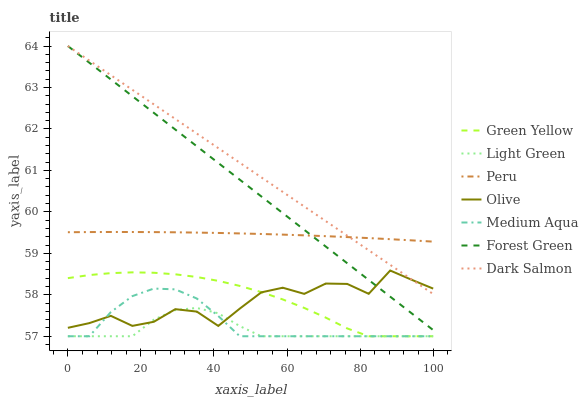Does Light Green have the minimum area under the curve?
Answer yes or no. Yes. Does Dark Salmon have the maximum area under the curve?
Answer yes or no. Yes. Does Forest Green have the minimum area under the curve?
Answer yes or no. No. Does Forest Green have the maximum area under the curve?
Answer yes or no. No. Is Forest Green the smoothest?
Answer yes or no. Yes. Is Olive the roughest?
Answer yes or no. Yes. Is Dark Salmon the smoothest?
Answer yes or no. No. Is Dark Salmon the roughest?
Answer yes or no. No. Does Dark Salmon have the lowest value?
Answer yes or no. No. Does Forest Green have the highest value?
Answer yes or no. Yes. Does Medium Aqua have the highest value?
Answer yes or no. No. Is Green Yellow less than Forest Green?
Answer yes or no. Yes. Is Peru greater than Medium Aqua?
Answer yes or no. Yes. Does Olive intersect Forest Green?
Answer yes or no. Yes. Is Olive less than Forest Green?
Answer yes or no. No. Is Olive greater than Forest Green?
Answer yes or no. No. Does Green Yellow intersect Forest Green?
Answer yes or no. No. 